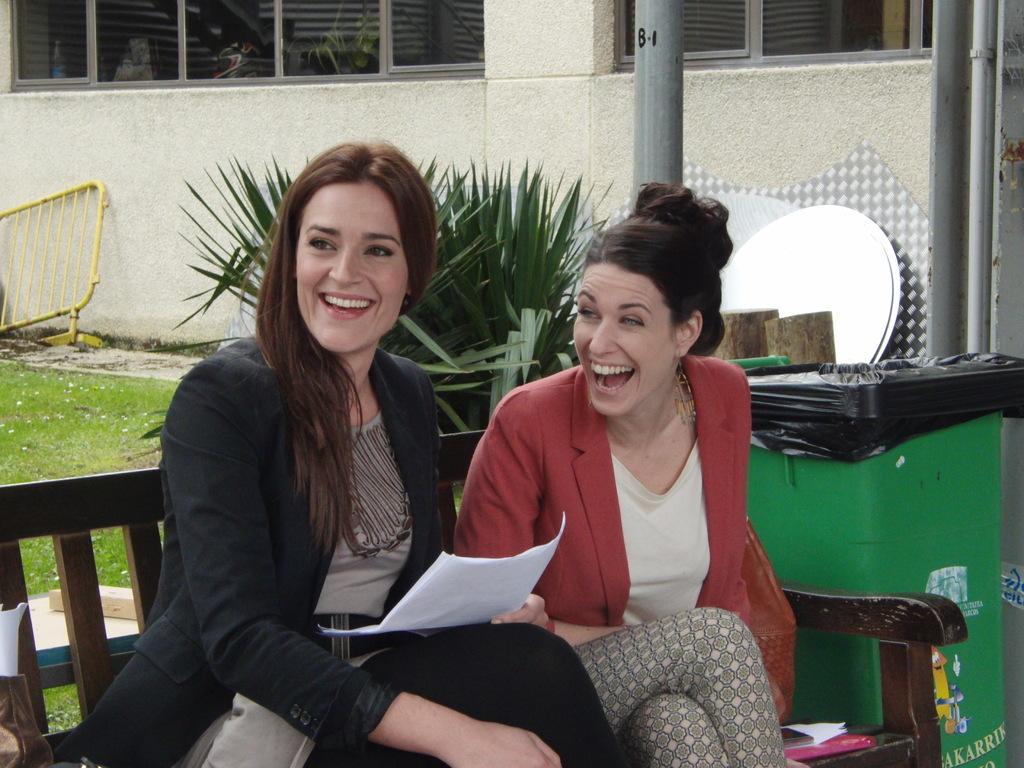Describe this image in one or two sentences. In the foreground of the picture there are two women sitting in a bench, they are smiling. Behind them they are dustbin, plants, poles, pipes and some iron objects. In the background there are grass, windows, gate and wall. 